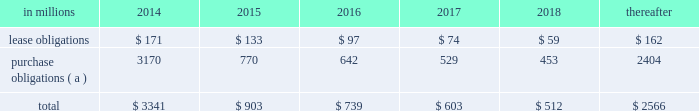At december 31 , 2013 , total future minimum commitments under existing non-cancelable operating leases and purchase obligations were as follows: .
( a ) includes $ 3.3 billion relating to fiber supply agreements entered into at the time of the company 2019s 2006 transformation plan forestland sales and in conjunction with the 2008 acquisition of weyerhaeuser company 2019s containerboard , packaging and recycling business .
Rent expense was $ 215 million , $ 231 million and $ 205 million for 2013 , 2012 and 2011 , respectively .
Guarantees in connection with sales of businesses , property , equipment , forestlands and other assets , international paper commonly makes representations and warranties relating to such businesses or assets , and may agree to indemnify buyers with respect to tax and environmental liabilities , breaches of representations and warranties , and other matters .
Where liabilities for such matters are determined to be probable and subject to reasonable estimation , accrued liabilities are recorded at the time of sale as a cost of the transaction .
Environmental proceedings international paper has been named as a potentially responsible party in environmental remediation actions under various federal and state laws , including the comprehensive environmental response , compensation and liability act ( cercla ) .
Many of these proceedings involve the cleanup of hazardous substances at large commercial landfills that received waste from many different sources .
While joint and several liability is authorized under cercla and equivalent state laws , as a practical matter , liability for cercla cleanups is typically allocated among the many potential responsible parties .
Remedial costs are recorded in the consolidated financial statements when they become probable and reasonably estimable .
International paper has estimated the probable liability associated with these matters to be approximately $ 94 million in the aggregate at december 31 , 2013 .
Cass lake : one of the matters referenced above is a closed wood treating facility located in cass lake , minnesota .
During 2009 , in connection with an environmental site remediation action under cercla , international paper submitted to the epa a site remediation feasibility study .
In june 2011 , the epa selected and published a proposed soil remedy at the site with an estimated cost of $ 46 million .
The overall remediation reserve for the site is currently $ 51 million to address this selection of an alternative for the soil remediation component of the overall site remedy .
In october 2011 , the epa released a public statement indicating that the final soil remedy decision would be delayed .
In the unlikely event that the epa changes its proposed soil remedy and approves instead a more expensive clean-up alternative , the remediation costs could be material , and significantly higher than amounts currently recorded .
In october 2012 , the natural resource trustees for this site provided notice to international paper and other potentially responsible parties of their intent to perform a natural resource damage assessment .
It is premature to predict the outcome of the assessment or to estimate a loss or range of loss , if any , which may be incurred .
Other : in addition to the above matters , other remediation costs typically associated with the cleanup of hazardous substances at the company 2019s current , closed or formerly-owned facilities , and recorded as liabilities in the balance sheet , totaled approximately $ 42 million at december 31 , 2013 .
Other than as described above , completion of required remedial actions is not expected to have a material effect on our consolidated financial statements .
Kalamazoo river : the company is a potentially responsible party with respect to the allied paper , inc./ portage creek/kalamazoo river superfund site ( kalamazoo river superfund site ) in michigan .
The epa asserts that the site is contaminated primarily by pcbs as a result of discharges from various paper mills located along the kalamazoo river , including a paper mill formerly owned by st .
Regis paper company ( st .
Regis ) .
The company is a successor in interest to st .
Regis .
The company has not received any orders from the epa with respect to the site and continues to collect information from the epa and other parties relative to the site to evaluate the extent of its liability , if any , with respect to the site .
Accordingly , it is premature to estimate a loss or range of loss with respect to this site .
Also in connection with the kalamazoo river superfund site , the company was named as a defendant by georgia-pacific consumer products lp , fort james corporation and georgia pacific llc in a contribution and cost recovery action for alleged pollution at the site .
The suit seeks contribution under cercla for $ 79 million in costs purportedly expended by plaintiffs as of the filing of the complaint and for future remediation costs .
The suit alleges that a mill , during the time it was allegedly owned and operated by st .
Regis , discharged pcb contaminated solids and paper residuals resulting from paper de-inking and recycling .
Also named as defendants in the suit are ncr corporation and weyerhaeuser company .
In mid-2011 , the suit was transferred from the district court for the eastern district of wisconsin to the district court for the western .
What was the ratio of the lease obligations to purchase obligations? 
Computations: (59 / 453)
Answer: 0.13024. 